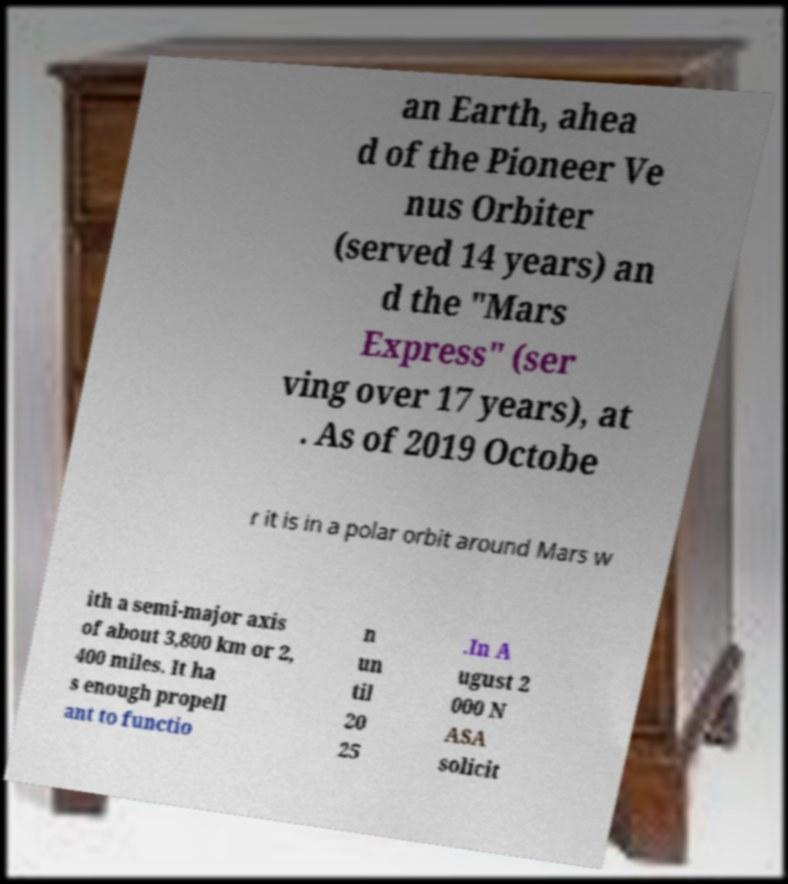Could you assist in decoding the text presented in this image and type it out clearly? an Earth, ahea d of the Pioneer Ve nus Orbiter (served 14 years) an d the "Mars Express" (ser ving over 17 years), at . As of 2019 Octobe r it is in a polar orbit around Mars w ith a semi-major axis of about 3,800 km or 2, 400 miles. It ha s enough propell ant to functio n un til 20 25 .In A ugust 2 000 N ASA solicit 